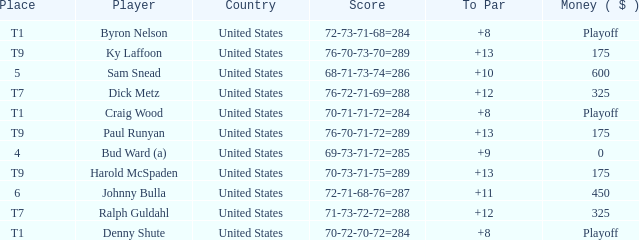What is the total amount sam snead won? 600.0. 